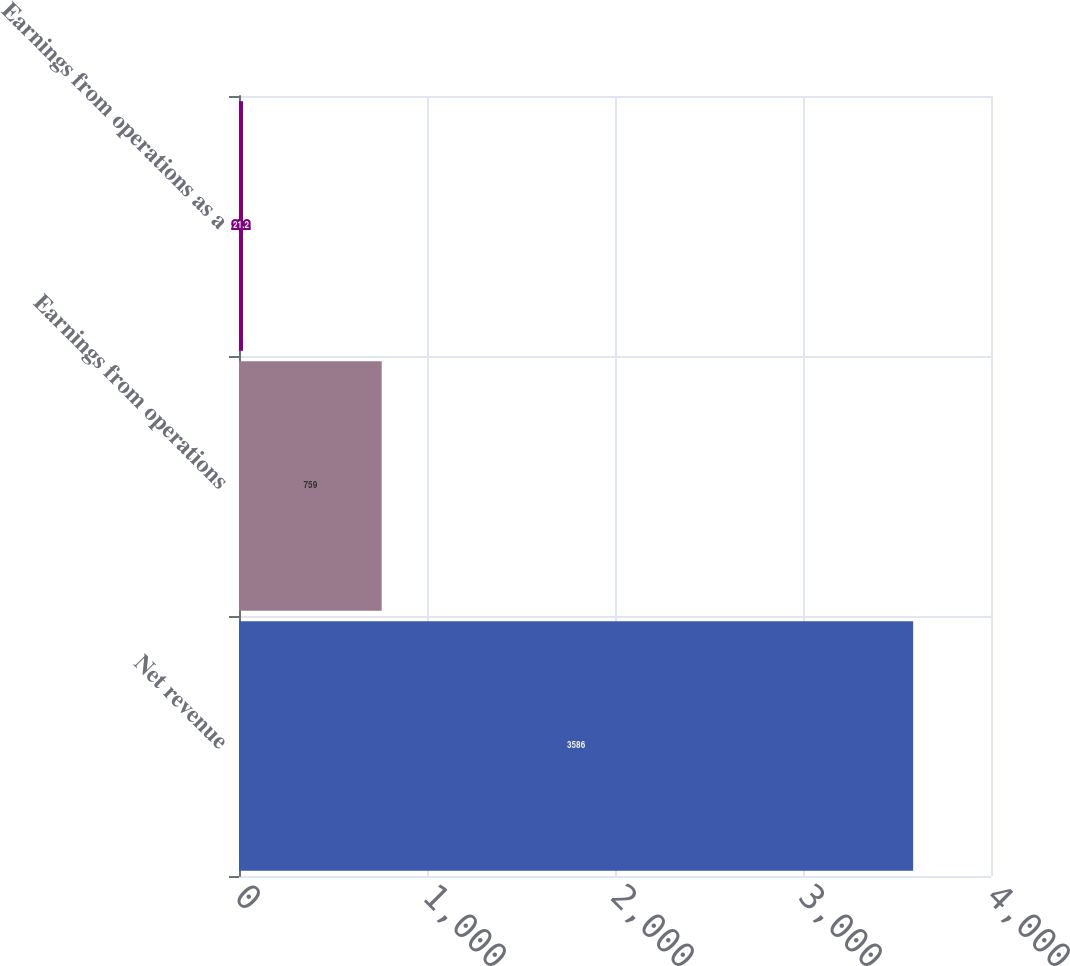<chart> <loc_0><loc_0><loc_500><loc_500><bar_chart><fcel>Net revenue<fcel>Earnings from operations<fcel>Earnings from operations as a<nl><fcel>3586<fcel>759<fcel>21.2<nl></chart> 